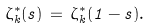Convert formula to latex. <formula><loc_0><loc_0><loc_500><loc_500>\zeta _ { k } ^ { * } ( s ) \, = \, \zeta _ { k } ^ { * } ( 1 - s ) .</formula> 